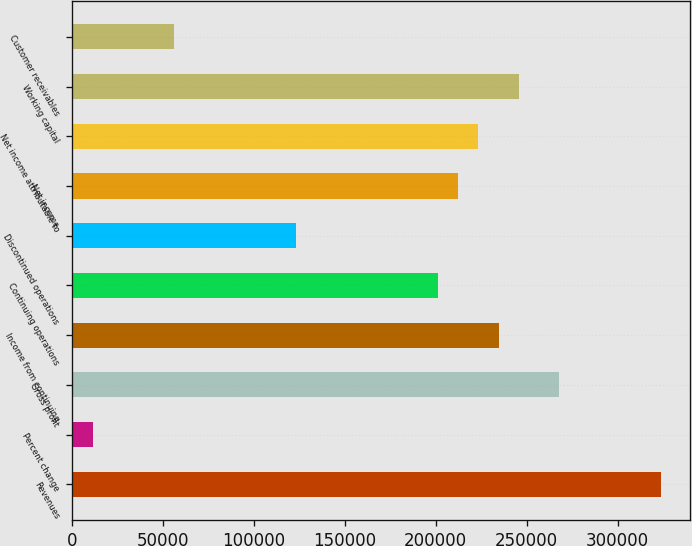<chart> <loc_0><loc_0><loc_500><loc_500><bar_chart><fcel>Revenues<fcel>Percent change<fcel>Gross profit<fcel>Income from continuing<fcel>Continuing operations<fcel>Discontinued operations<fcel>Net income<fcel>Net income attributable to<fcel>Working capital<fcel>Customer receivables<nl><fcel>323862<fcel>11168.4<fcel>268024<fcel>234521<fcel>201018<fcel>122845<fcel>212186<fcel>223353<fcel>245689<fcel>55838.9<nl></chart> 